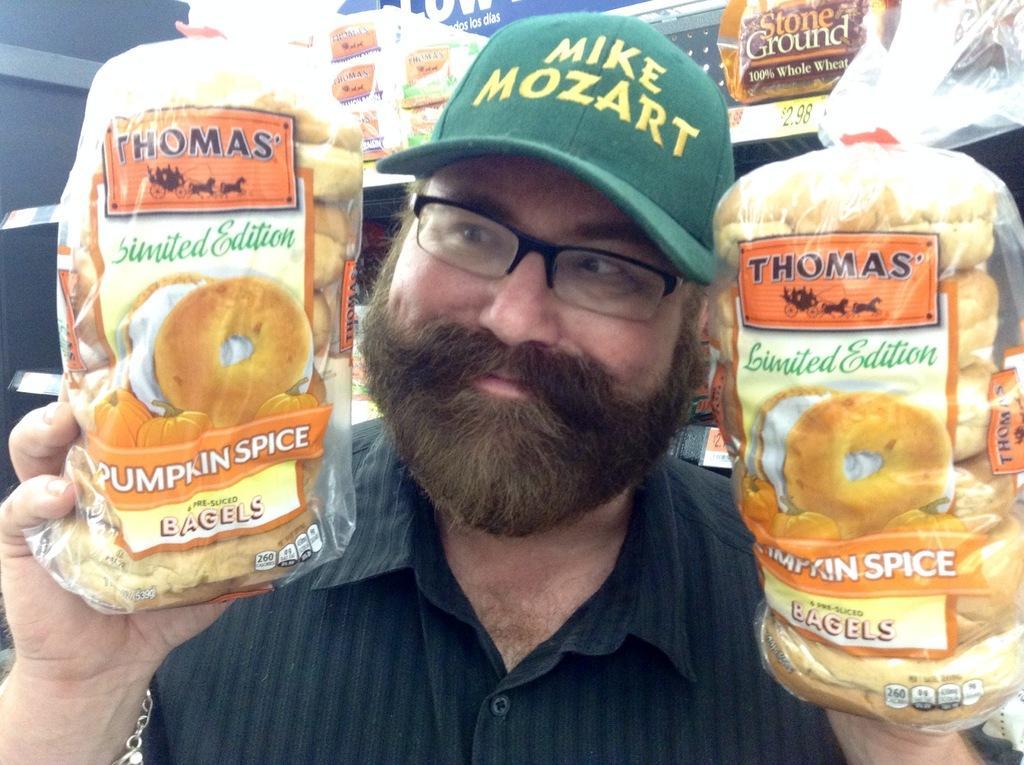Can you describe this image briefly? In this picture, we can see a person holding some objects, in the background, we can see the wall with shelves and some objects on it, we can see some posters with numbers on the shelves. 